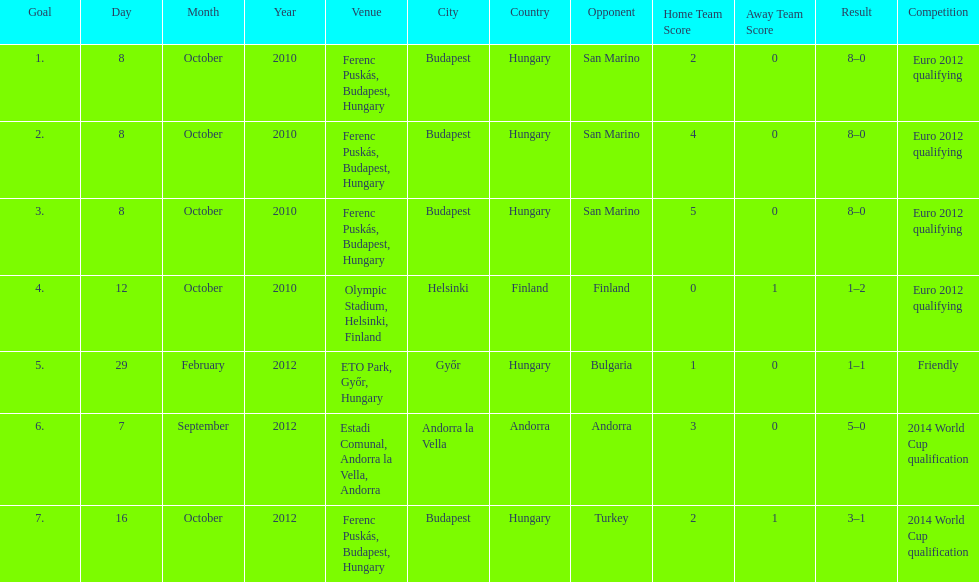When did ádám szalai make his first international goal? 8 October 2010. 